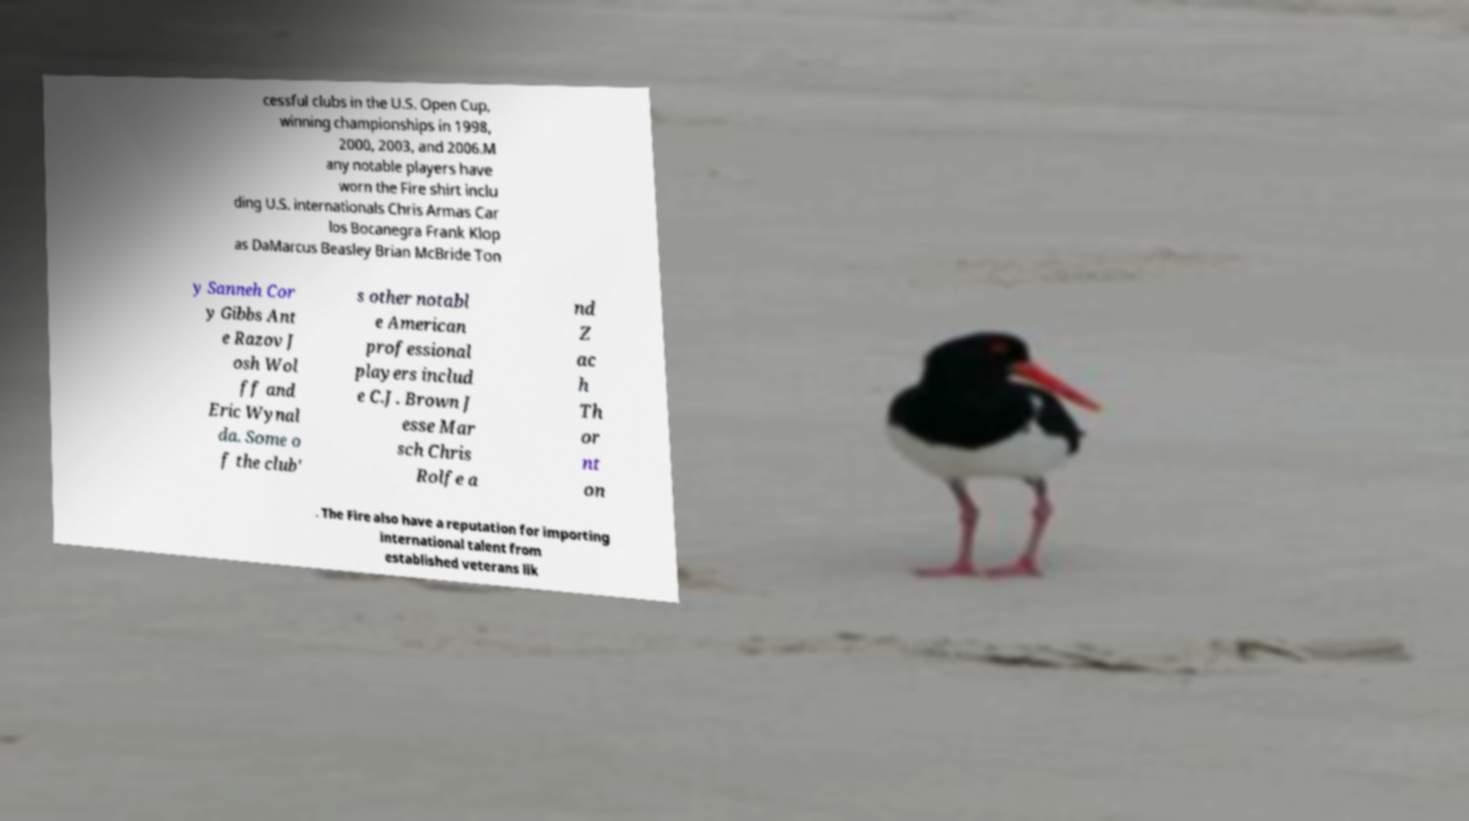Please identify and transcribe the text found in this image. cessful clubs in the U.S. Open Cup, winning championships in 1998, 2000, 2003, and 2006.M any notable players have worn the Fire shirt inclu ding U.S. internationals Chris Armas Car los Bocanegra Frank Klop as DaMarcus Beasley Brian McBride Ton y Sanneh Cor y Gibbs Ant e Razov J osh Wol ff and Eric Wynal da. Some o f the club' s other notabl e American professional players includ e C.J. Brown J esse Mar sch Chris Rolfe a nd Z ac h Th or nt on . The Fire also have a reputation for importing international talent from established veterans lik 